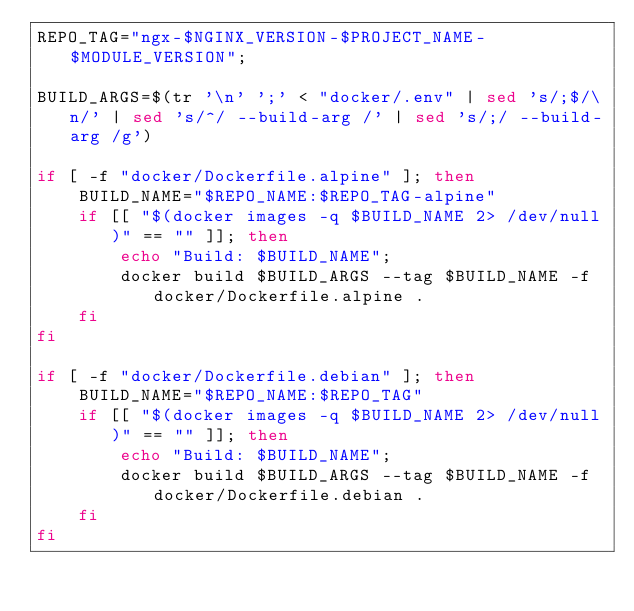<code> <loc_0><loc_0><loc_500><loc_500><_Bash_>REPO_TAG="ngx-$NGINX_VERSION-$PROJECT_NAME-$MODULE_VERSION";

BUILD_ARGS=$(tr '\n' ';' < "docker/.env" | sed 's/;$/\n/' | sed 's/^/ --build-arg /' | sed 's/;/ --build-arg /g')

if [ -f "docker/Dockerfile.alpine" ]; then
    BUILD_NAME="$REPO_NAME:$REPO_TAG-alpine"
    if [[ "$(docker images -q $BUILD_NAME 2> /dev/null)" == "" ]]; then
        echo "Build: $BUILD_NAME";
        docker build $BUILD_ARGS --tag $BUILD_NAME -f docker/Dockerfile.alpine .
    fi
fi

if [ -f "docker/Dockerfile.debian" ]; then
    BUILD_NAME="$REPO_NAME:$REPO_TAG"
    if [[ "$(docker images -q $BUILD_NAME 2> /dev/null)" == "" ]]; then
        echo "Build: $BUILD_NAME";
        docker build $BUILD_ARGS --tag $BUILD_NAME -f docker/Dockerfile.debian .
    fi
fi
</code> 